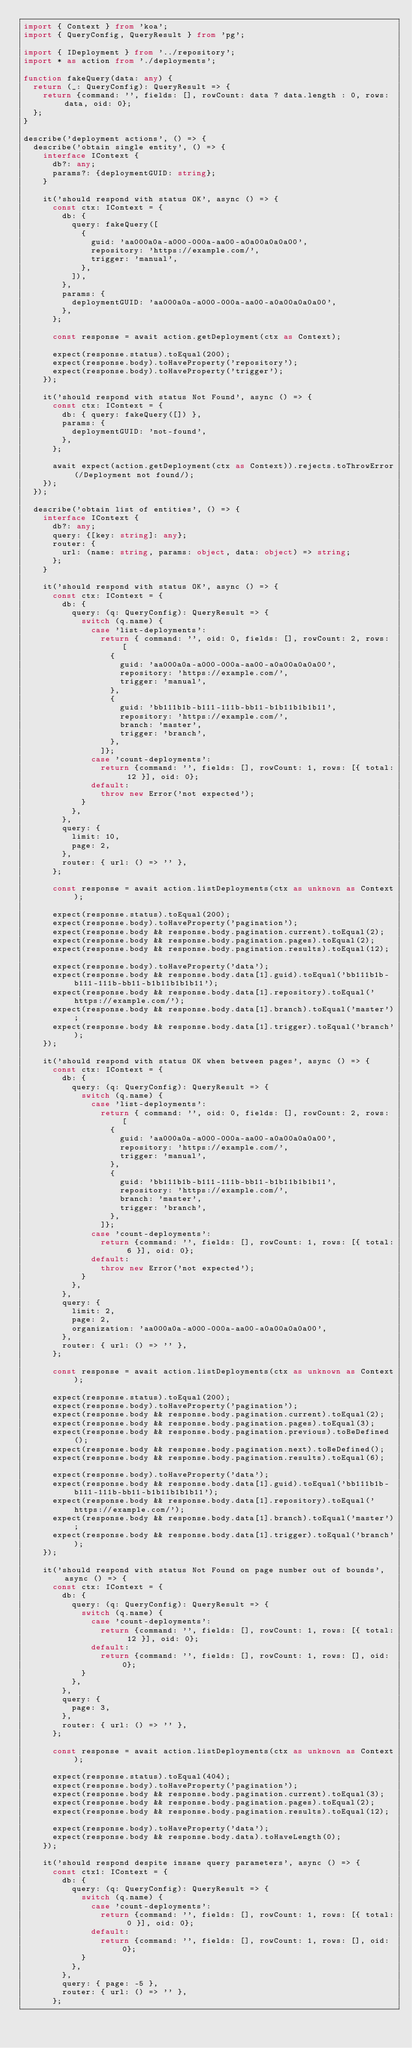<code> <loc_0><loc_0><loc_500><loc_500><_TypeScript_>import { Context } from 'koa';
import { QueryConfig, QueryResult } from 'pg';

import { IDeployment } from '../repository';
import * as action from './deployments';

function fakeQuery(data: any) {
  return (_: QueryConfig): QueryResult => {
    return {command: '', fields: [], rowCount: data ? data.length : 0, rows: data, oid: 0};
  };
}

describe('deployment actions', () => {
  describe('obtain single entity', () => {
    interface IContext {
      db?: any;
      params?: {deploymentGUID: string};
    }

    it('should respond with status OK', async () => {
      const ctx: IContext = {
        db: {
          query: fakeQuery([
            {
              guid: 'aa000a0a-a000-000a-aa00-a0a00a0a0a00',
              repository: 'https://example.com/',
              trigger: 'manual',
            },
          ]),
        },
        params: {
          deploymentGUID: 'aa000a0a-a000-000a-aa00-a0a00a0a0a00',
        },
      };

      const response = await action.getDeployment(ctx as Context);

      expect(response.status).toEqual(200);
      expect(response.body).toHaveProperty('repository');
      expect(response.body).toHaveProperty('trigger');
    });

    it('should respond with status Not Found', async () => {
      const ctx: IContext = {
        db: { query: fakeQuery([]) },
        params: {
          deploymentGUID: 'not-found',
        },
      };

      await expect(action.getDeployment(ctx as Context)).rejects.toThrowError(/Deployment not found/);
    });
  });

  describe('obtain list of entities', () => {
    interface IContext {
      db?: any;
      query: {[key: string]: any};
      router: {
        url: (name: string, params: object, data: object) => string;
      };
    }

    it('should respond with status OK', async () => {
      const ctx: IContext = {
        db: {
          query: (q: QueryConfig): QueryResult => {
            switch (q.name) {
              case 'list-deployments':
                return { command: '', oid: 0, fields: [], rowCount: 2, rows: [
                  {
                    guid: 'aa000a0a-a000-000a-aa00-a0a00a0a0a00',
                    repository: 'https://example.com/',
                    trigger: 'manual',
                  },
                  {
                    guid: 'bb111b1b-b111-111b-bb11-b1b11b1b1b11',
                    repository: 'https://example.com/',
                    branch: 'master',
                    trigger: 'branch',
                  },
                ]};
              case 'count-deployments':
                return {command: '', fields: [], rowCount: 1, rows: [{ total: 12 }], oid: 0};
              default:
                throw new Error('not expected');
            }
          },
        },
        query: {
          limit: 10,
          page: 2,
        },
        router: { url: () => '' },
      };

      const response = await action.listDeployments(ctx as unknown as Context);

      expect(response.status).toEqual(200);
      expect(response.body).toHaveProperty('pagination');
      expect(response.body && response.body.pagination.current).toEqual(2);
      expect(response.body && response.body.pagination.pages).toEqual(2);
      expect(response.body && response.body.pagination.results).toEqual(12);

      expect(response.body).toHaveProperty('data');
      expect(response.body && response.body.data[1].guid).toEqual('bb111b1b-b111-111b-bb11-b1b11b1b1b11');
      expect(response.body && response.body.data[1].repository).toEqual('https://example.com/');
      expect(response.body && response.body.data[1].branch).toEqual('master');
      expect(response.body && response.body.data[1].trigger).toEqual('branch');
    });

    it('should respond with status OK when between pages', async () => {
      const ctx: IContext = {
        db: {
          query: (q: QueryConfig): QueryResult => {
            switch (q.name) {
              case 'list-deployments':
                return { command: '', oid: 0, fields: [], rowCount: 2, rows: [
                  {
                    guid: 'aa000a0a-a000-000a-aa00-a0a00a0a0a00',
                    repository: 'https://example.com/',
                    trigger: 'manual',
                  },
                  {
                    guid: 'bb111b1b-b111-111b-bb11-b1b11b1b1b11',
                    repository: 'https://example.com/',
                    branch: 'master',
                    trigger: 'branch',
                  },
                ]};
              case 'count-deployments':
                return {command: '', fields: [], rowCount: 1, rows: [{ total: 6 }], oid: 0};
              default:
                throw new Error('not expected');
            }
          },
        },
        query: {
          limit: 2,
          page: 2,
          organization: 'aa000a0a-a000-000a-aa00-a0a00a0a0a00',
        },
        router: { url: () => '' },
      };

      const response = await action.listDeployments(ctx as unknown as Context);

      expect(response.status).toEqual(200);
      expect(response.body).toHaveProperty('pagination');
      expect(response.body && response.body.pagination.current).toEqual(2);
      expect(response.body && response.body.pagination.pages).toEqual(3);
      expect(response.body && response.body.pagination.previous).toBeDefined();
      expect(response.body && response.body.pagination.next).toBeDefined();
      expect(response.body && response.body.pagination.results).toEqual(6);

      expect(response.body).toHaveProperty('data');
      expect(response.body && response.body.data[1].guid).toEqual('bb111b1b-b111-111b-bb11-b1b11b1b1b11');
      expect(response.body && response.body.data[1].repository).toEqual('https://example.com/');
      expect(response.body && response.body.data[1].branch).toEqual('master');
      expect(response.body && response.body.data[1].trigger).toEqual('branch');
    });

    it('should respond with status Not Found on page number out of bounds', async () => {
      const ctx: IContext = {
        db: {
          query: (q: QueryConfig): QueryResult => {
            switch (q.name) {
              case 'count-deployments':
                return {command: '', fields: [], rowCount: 1, rows: [{ total: 12 }], oid: 0};
              default:
                return {command: '', fields: [], rowCount: 1, rows: [], oid: 0};
            }
          },
        },
        query: {
          page: 3,
        },
        router: { url: () => '' },
      };

      const response = await action.listDeployments(ctx as unknown as Context);

      expect(response.status).toEqual(404);
      expect(response.body).toHaveProperty('pagination');
      expect(response.body && response.body.pagination.current).toEqual(3);
      expect(response.body && response.body.pagination.pages).toEqual(2);
      expect(response.body && response.body.pagination.results).toEqual(12);

      expect(response.body).toHaveProperty('data');
      expect(response.body && response.body.data).toHaveLength(0);
    });

    it('should respond despite insane query parameters', async () => {
      const ctx1: IContext = {
        db: {
          query: (q: QueryConfig): QueryResult => {
            switch (q.name) {
              case 'count-deployments':
                return {command: '', fields: [], rowCount: 1, rows: [{ total: 0 }], oid: 0};
              default:
                return {command: '', fields: [], rowCount: 1, rows: [], oid: 0};
            }
          },
        },
        query: { page: -5 },
        router: { url: () => '' },
      };
</code> 